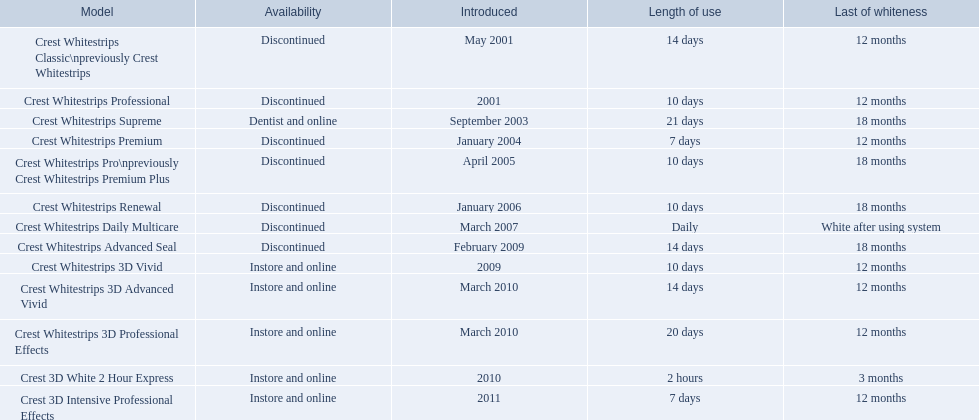What are all the model designations? Crest Whitestrips Classic\npreviously Crest Whitestrips, Crest Whitestrips Professional, Crest Whitestrips Supreme, Crest Whitestrips Premium, Crest Whitestrips Pro\npreviously Crest Whitestrips Premium Plus, Crest Whitestrips Renewal, Crest Whitestrips Daily Multicare, Crest Whitestrips Advanced Seal, Crest Whitestrips 3D Vivid, Crest Whitestrips 3D Advanced Vivid, Crest Whitestrips 3D Professional Effects, Crest 3D White 2 Hour Express, Crest 3D Intensive Professional Effects. When were they initially presented? May 2001, 2001, September 2003, January 2004, April 2005, January 2006, March 2007, February 2009, 2009, March 2010, March 2010, 2010, 2011. In addition to crest whitestrips 3d advanced vivid, which other model was introduced in march 2010? Crest Whitestrips 3D Professional Effects. 